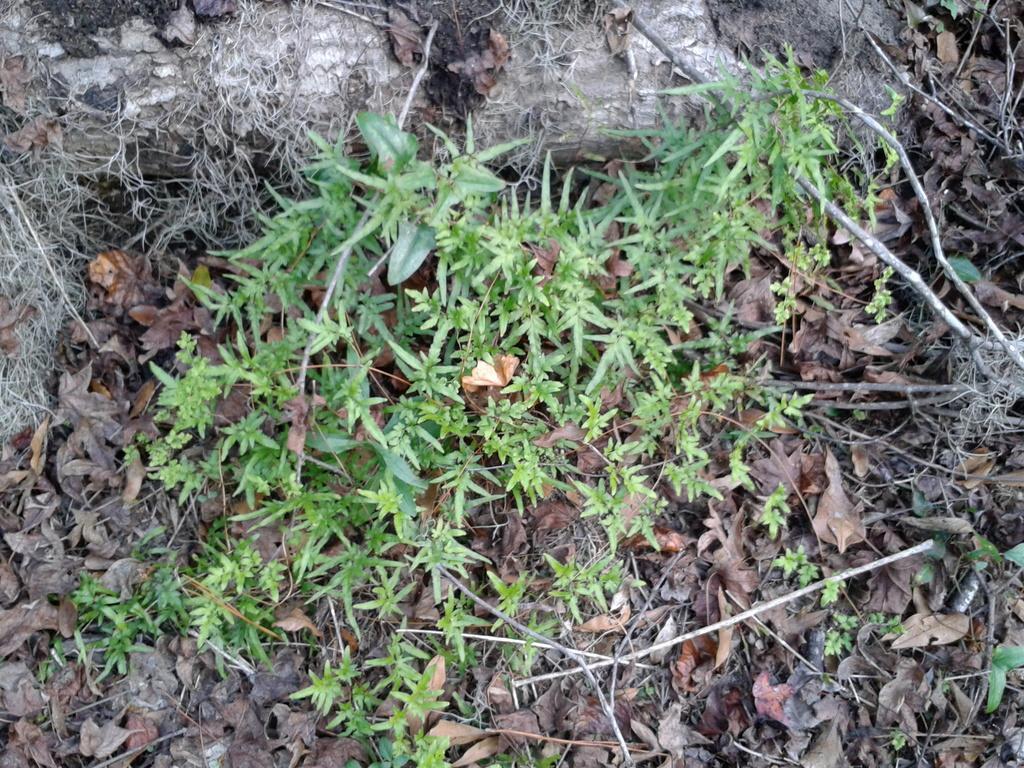In one or two sentences, can you explain what this image depicts? In this image we can see small plants on the land and dry leaves and stems are also there. 